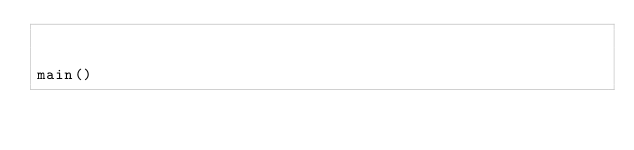<code> <loc_0><loc_0><loc_500><loc_500><_Python_>

main()
</code> 